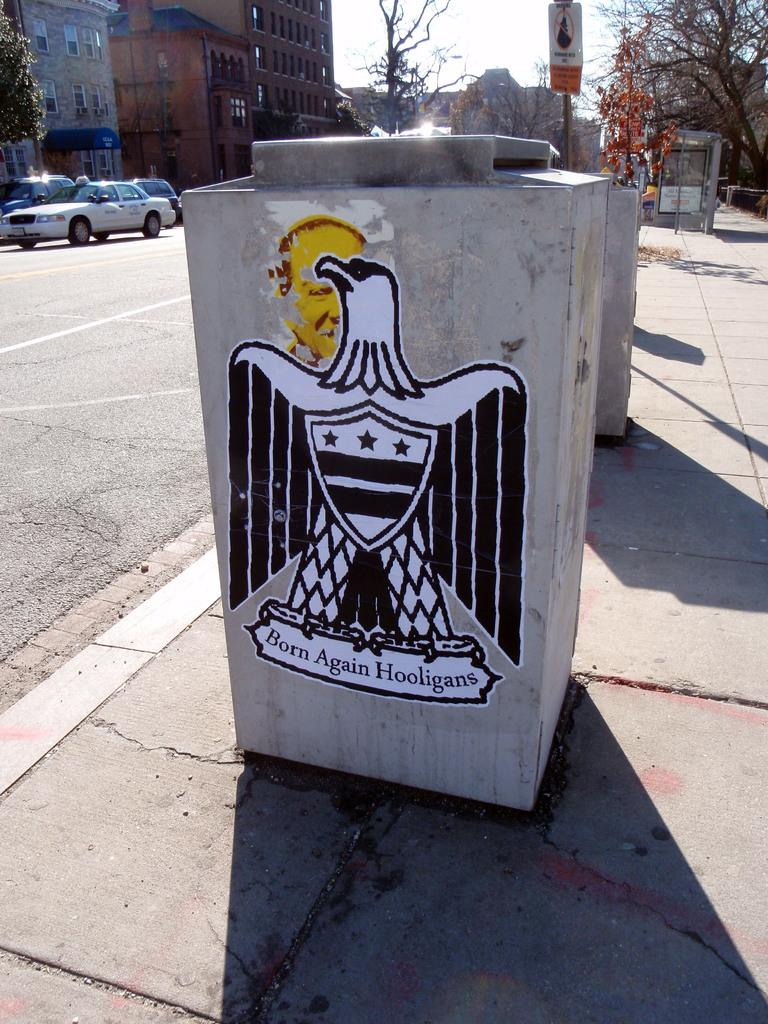Provide a one-sentence caption for the provided image. A cement block has an eagle drawing and says Born Again Hooligans on it. 